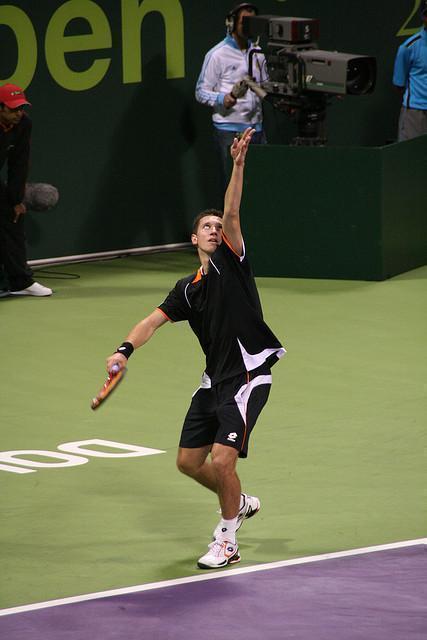What is the player about to do?
Select the accurate answer and provide justification: `Answer: choice
Rationale: srationale.`
Options: Love, return, serve, fake out. Answer: serve.
Rationale: A tennis player is throwing the ball in the area near the backline. serving is done at the back line. 